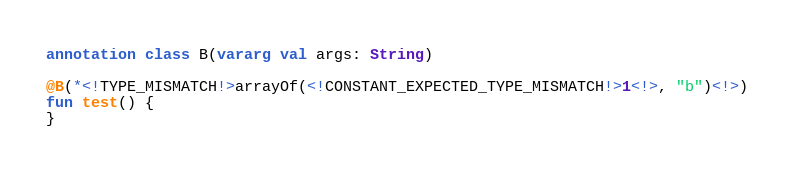Convert code to text. <code><loc_0><loc_0><loc_500><loc_500><_Kotlin_>annotation class B(vararg val args: String)

@B(*<!TYPE_MISMATCH!>arrayOf(<!CONSTANT_EXPECTED_TYPE_MISMATCH!>1<!>, "b")<!>)
fun test() {
}
</code> 